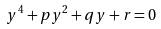<formula> <loc_0><loc_0><loc_500><loc_500>y ^ { 4 } + p y ^ { 2 } + q y + r = 0</formula> 